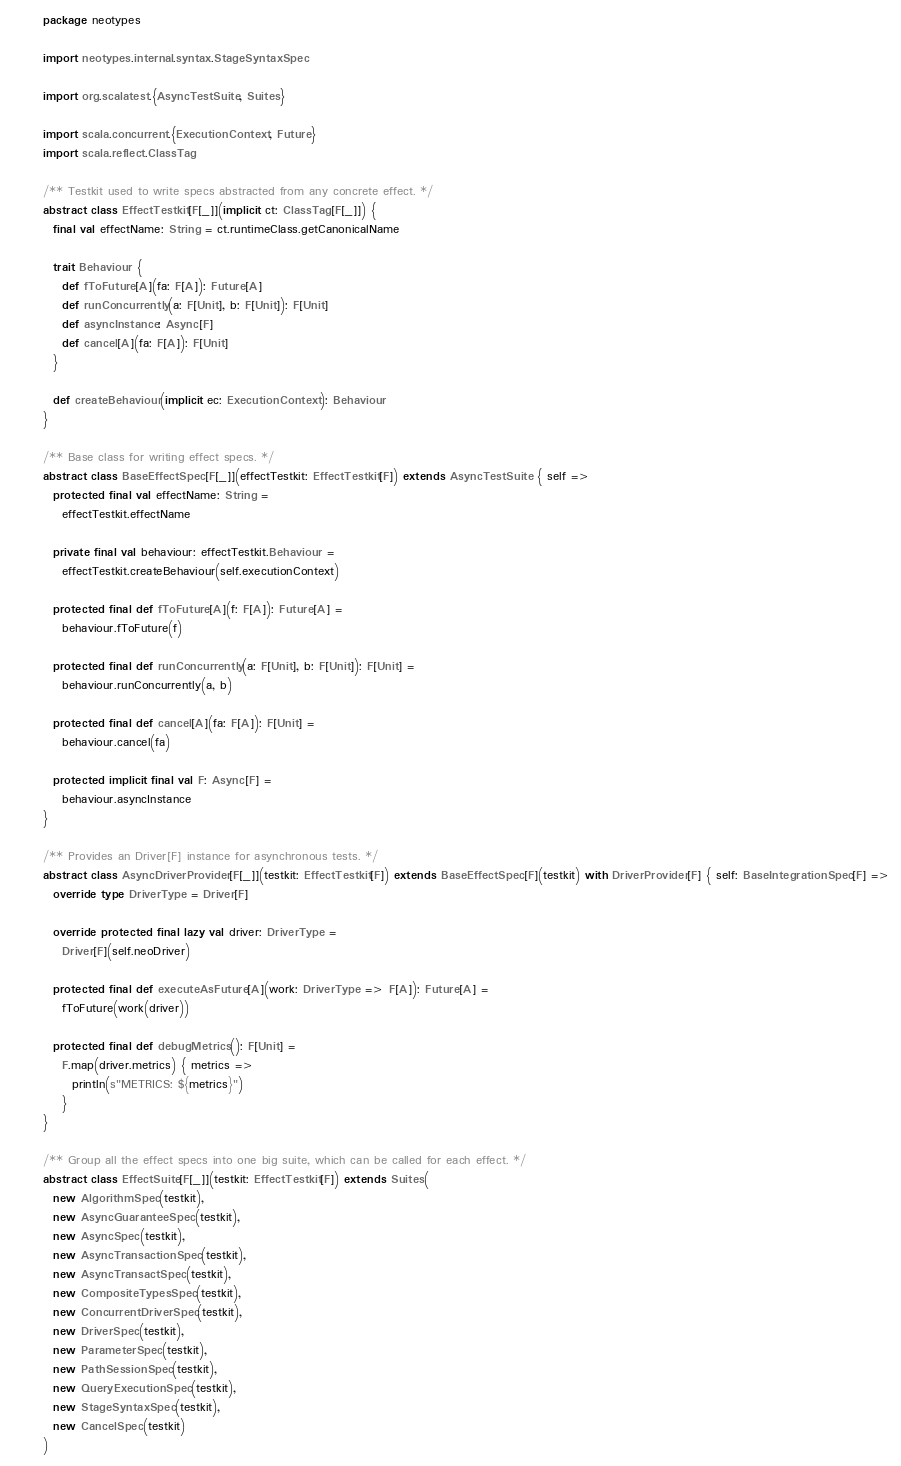Convert code to text. <code><loc_0><loc_0><loc_500><loc_500><_Scala_>package neotypes

import neotypes.internal.syntax.StageSyntaxSpec

import org.scalatest.{AsyncTestSuite, Suites}

import scala.concurrent.{ExecutionContext, Future}
import scala.reflect.ClassTag

/** Testkit used to write specs abstracted from any concrete effect. */
abstract class EffectTestkit[F[_]](implicit ct: ClassTag[F[_]]) {
  final val effectName: String = ct.runtimeClass.getCanonicalName

  trait Behaviour {
    def fToFuture[A](fa: F[A]): Future[A]
    def runConcurrently(a: F[Unit], b: F[Unit]): F[Unit]
    def asyncInstance: Async[F]
    def cancel[A](fa: F[A]): F[Unit]
  }

  def createBehaviour(implicit ec: ExecutionContext): Behaviour
}

/** Base class for writing effect specs. */
abstract class BaseEffectSpec[F[_]](effectTestkit: EffectTestkit[F]) extends AsyncTestSuite { self =>
  protected final val effectName: String =
    effectTestkit.effectName

  private final val behaviour: effectTestkit.Behaviour =
    effectTestkit.createBehaviour(self.executionContext)

  protected final def fToFuture[A](f: F[A]): Future[A] =
    behaviour.fToFuture(f)

  protected final def runConcurrently(a: F[Unit], b: F[Unit]): F[Unit] =
    behaviour.runConcurrently(a, b)

  protected final def cancel[A](fa: F[A]): F[Unit] =
    behaviour.cancel(fa)

  protected implicit final val F: Async[F] =
    behaviour.asyncInstance
}

/** Provides an Driver[F] instance for asynchronous tests. */
abstract class AsyncDriverProvider[F[_]](testkit: EffectTestkit[F]) extends BaseEffectSpec[F](testkit) with DriverProvider[F] { self: BaseIntegrationSpec[F] =>
  override type DriverType = Driver[F]

  override protected final lazy val driver: DriverType =
    Driver[F](self.neoDriver)

  protected final def executeAsFuture[A](work: DriverType => F[A]): Future[A] =
    fToFuture(work(driver))

  protected final def debugMetrics(): F[Unit] =
    F.map(driver.metrics) { metrics =>
      println(s"METRICS: ${metrics}")
    }
}

/** Group all the effect specs into one big suite, which can be called for each effect. */
abstract class EffectSuite[F[_]](testkit: EffectTestkit[F]) extends Suites(
  new AlgorithmSpec(testkit),
  new AsyncGuaranteeSpec(testkit),
  new AsyncSpec(testkit),
  new AsyncTransactionSpec(testkit),
  new AsyncTransactSpec(testkit),
  new CompositeTypesSpec(testkit),
  new ConcurrentDriverSpec(testkit),
  new DriverSpec(testkit),
  new ParameterSpec(testkit),
  new PathSessionSpec(testkit),
  new QueryExecutionSpec(testkit),
  new StageSyntaxSpec(testkit),
  new CancelSpec(testkit)
)
</code> 